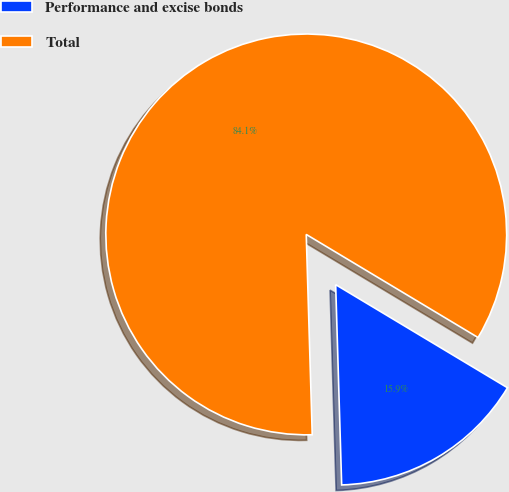<chart> <loc_0><loc_0><loc_500><loc_500><pie_chart><fcel>Performance and excise bonds<fcel>Total<nl><fcel>15.92%<fcel>84.08%<nl></chart> 